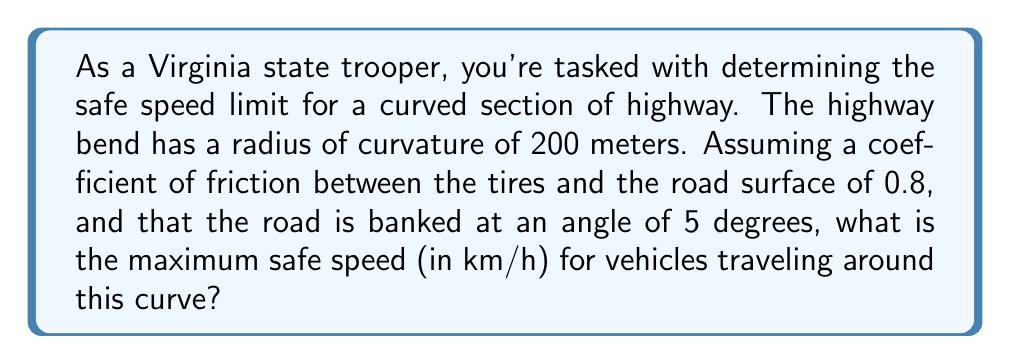Teach me how to tackle this problem. To solve this problem, we'll use the equation for the maximum speed on a banked curve, taking into account both the banking angle and the friction between the tires and the road.

The equation for the maximum speed $v$ on a banked curve is:

$$v = \sqrt{rg(\frac{\sin\theta + \mu\cos\theta}{\cos\theta - \mu\sin\theta})}$$

Where:
$r$ = radius of curvature (200 m)
$g$ = acceleration due to gravity (9.81 m/s²)
$\theta$ = banking angle (5 degrees)
$\mu$ = coefficient of friction (0.8)

Let's solve this step by step:

1) First, convert the banking angle from degrees to radians:
   $\theta = 5° \times \frac{\pi}{180°} = 0.0873$ radians

2) Now, let's calculate the components of the equation:
   $\sin\theta = \sin(0.0873) = 0.0872$
   $\cos\theta = \cos(0.0873) = 0.9962$

3) Substitute these values into the equation:

   $$v = \sqrt{200 \times 9.81 \times (\frac{0.0872 + 0.8 \times 0.9962}{0.9962 - 0.8 \times 0.0872})}$$

4) Simplify:
   $$v = \sqrt{1962 \times (\frac{0.8842}{0.9266})}$$
   $$v = \sqrt{1962 \times 0.9542}$$
   $$v = \sqrt{1872.1404}$$
   $$v = 43.27 \text{ m/s}$$

5) Convert this speed from m/s to km/h:
   $43.27 \text{ m/s} \times \frac{3600 \text{ s}}{1 \text{ h}} \times \frac{1 \text{ km}}{1000 \text{ m}} = 155.77 \text{ km/h}$

6) Round to the nearest whole number for practical application.
Answer: 156 km/h 